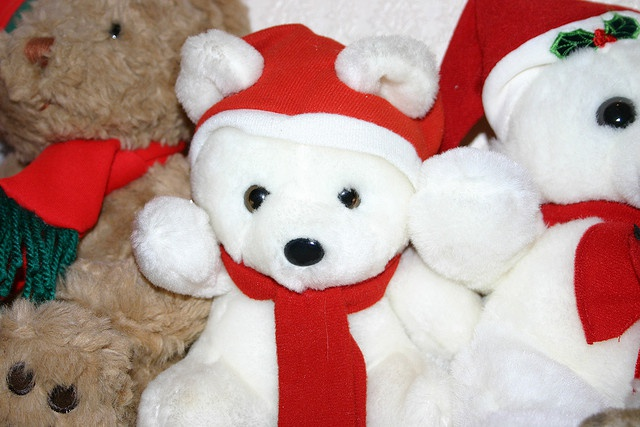Describe the objects in this image and their specific colors. I can see teddy bear in brown, lightgray, and darkgray tones, teddy bear in brown and gray tones, and teddy bear in brown, lightgray, darkgray, and black tones in this image. 